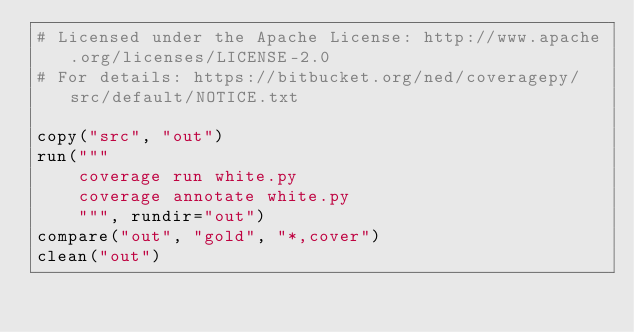Convert code to text. <code><loc_0><loc_0><loc_500><loc_500><_Python_># Licensed under the Apache License: http://www.apache.org/licenses/LICENSE-2.0
# For details: https://bitbucket.org/ned/coveragepy/src/default/NOTICE.txt

copy("src", "out")
run("""
    coverage run white.py
    coverage annotate white.py
    """, rundir="out")
compare("out", "gold", "*,cover")
clean("out")
</code> 